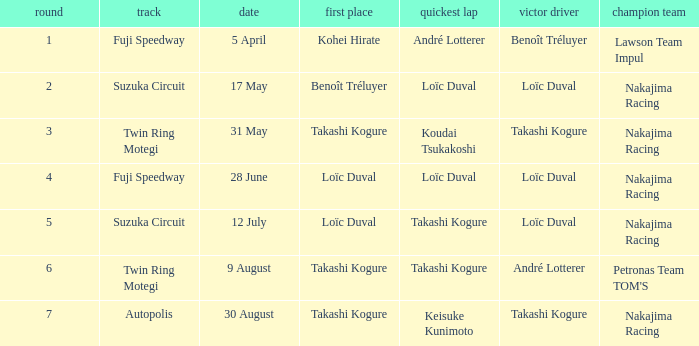Write the full table. {'header': ['round', 'track', 'date', 'first place', 'quickest lap', 'victor driver', 'champion team'], 'rows': [['1', 'Fuji Speedway', '5 April', 'Kohei Hirate', 'André Lotterer', 'Benoît Tréluyer', 'Lawson Team Impul'], ['2', 'Suzuka Circuit', '17 May', 'Benoît Tréluyer', 'Loïc Duval', 'Loïc Duval', 'Nakajima Racing'], ['3', 'Twin Ring Motegi', '31 May', 'Takashi Kogure', 'Koudai Tsukakoshi', 'Takashi Kogure', 'Nakajima Racing'], ['4', 'Fuji Speedway', '28 June', 'Loïc Duval', 'Loïc Duval', 'Loïc Duval', 'Nakajima Racing'], ['5', 'Suzuka Circuit', '12 July', 'Loïc Duval', 'Takashi Kogure', 'Loïc Duval', 'Nakajima Racing'], ['6', 'Twin Ring Motegi', '9 August', 'Takashi Kogure', 'Takashi Kogure', 'André Lotterer', "Petronas Team TOM'S"], ['7', 'Autopolis', '30 August', 'Takashi Kogure', 'Keisuke Kunimoto', 'Takashi Kogure', 'Nakajima Racing']]} What was the earlier round where Takashi Kogure got the fastest lap? 5.0. 